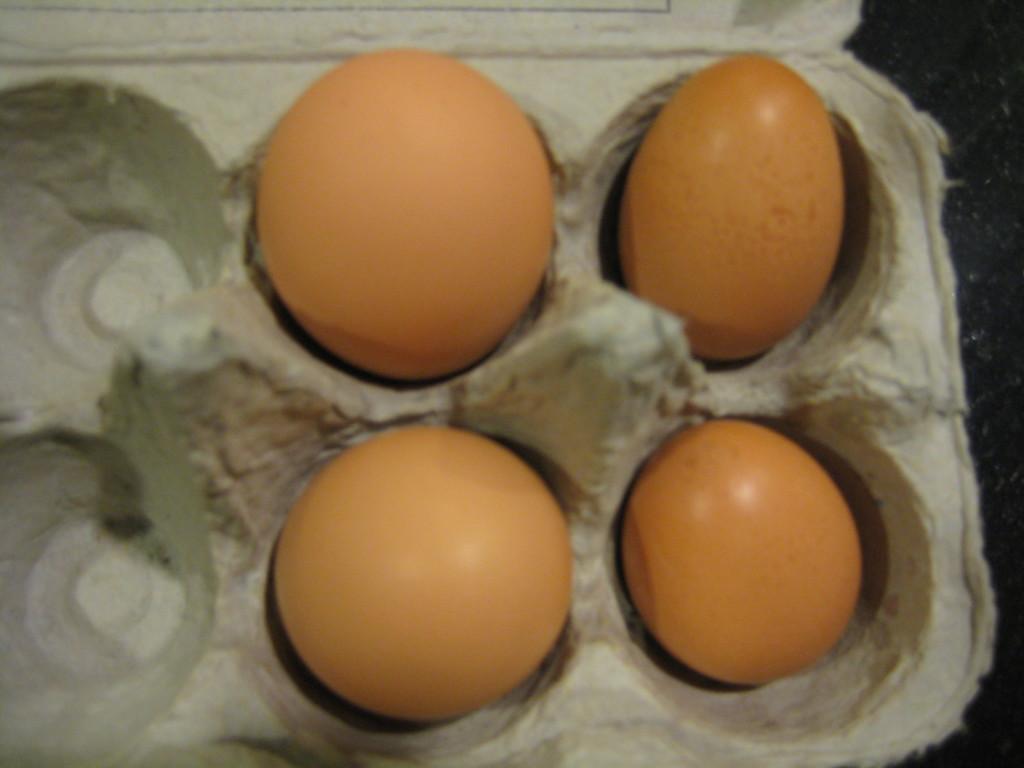Please provide a concise description of this image. In the image there are four eggs kept in an egg tray. 